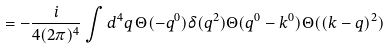<formula> <loc_0><loc_0><loc_500><loc_500>= - \frac { i } { 4 ( 2 \pi ) ^ { 4 } } \int d ^ { 4 } q \, \Theta ( - q ^ { 0 } ) \delta ( q ^ { 2 } ) \Theta ( q ^ { 0 } - k ^ { 0 } ) \Theta ( ( k - q ) ^ { 2 } )</formula> 